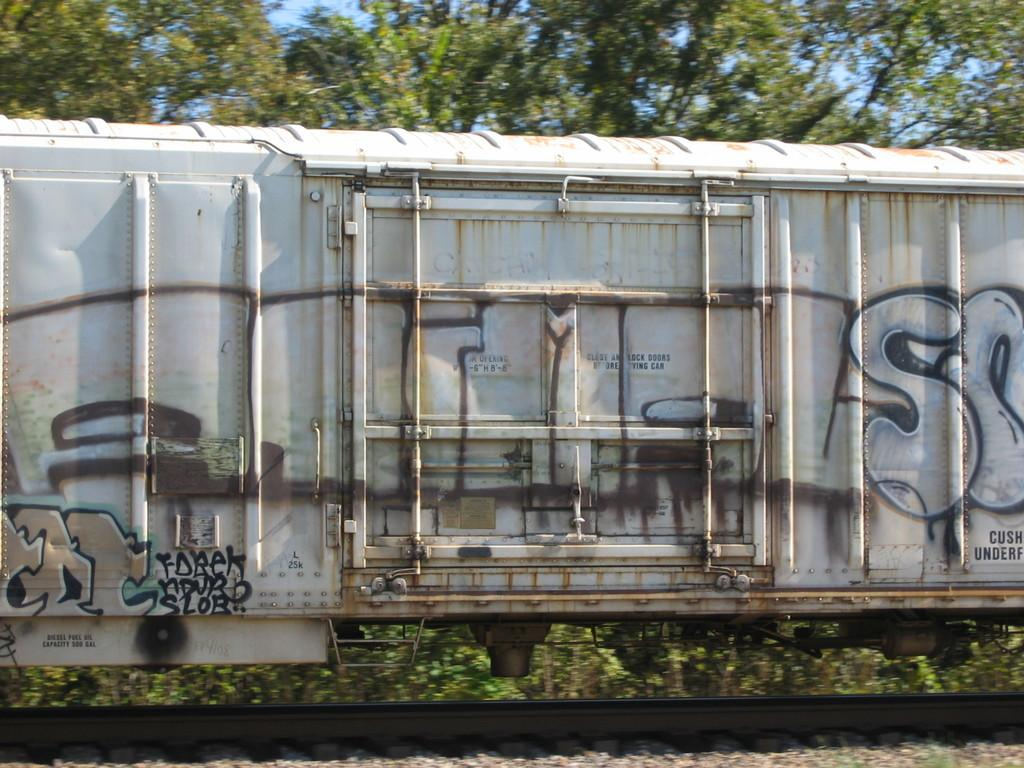What is the main subject of the image? The main subject of the image is a train. Where is the train located in the image? The train is on a track. What can be seen in the background of the image? There are trees beside the train. What type of dinner is being served on the train in the image? There is no dinner being served in the image; it only shows a train on a track with trees in the background. 